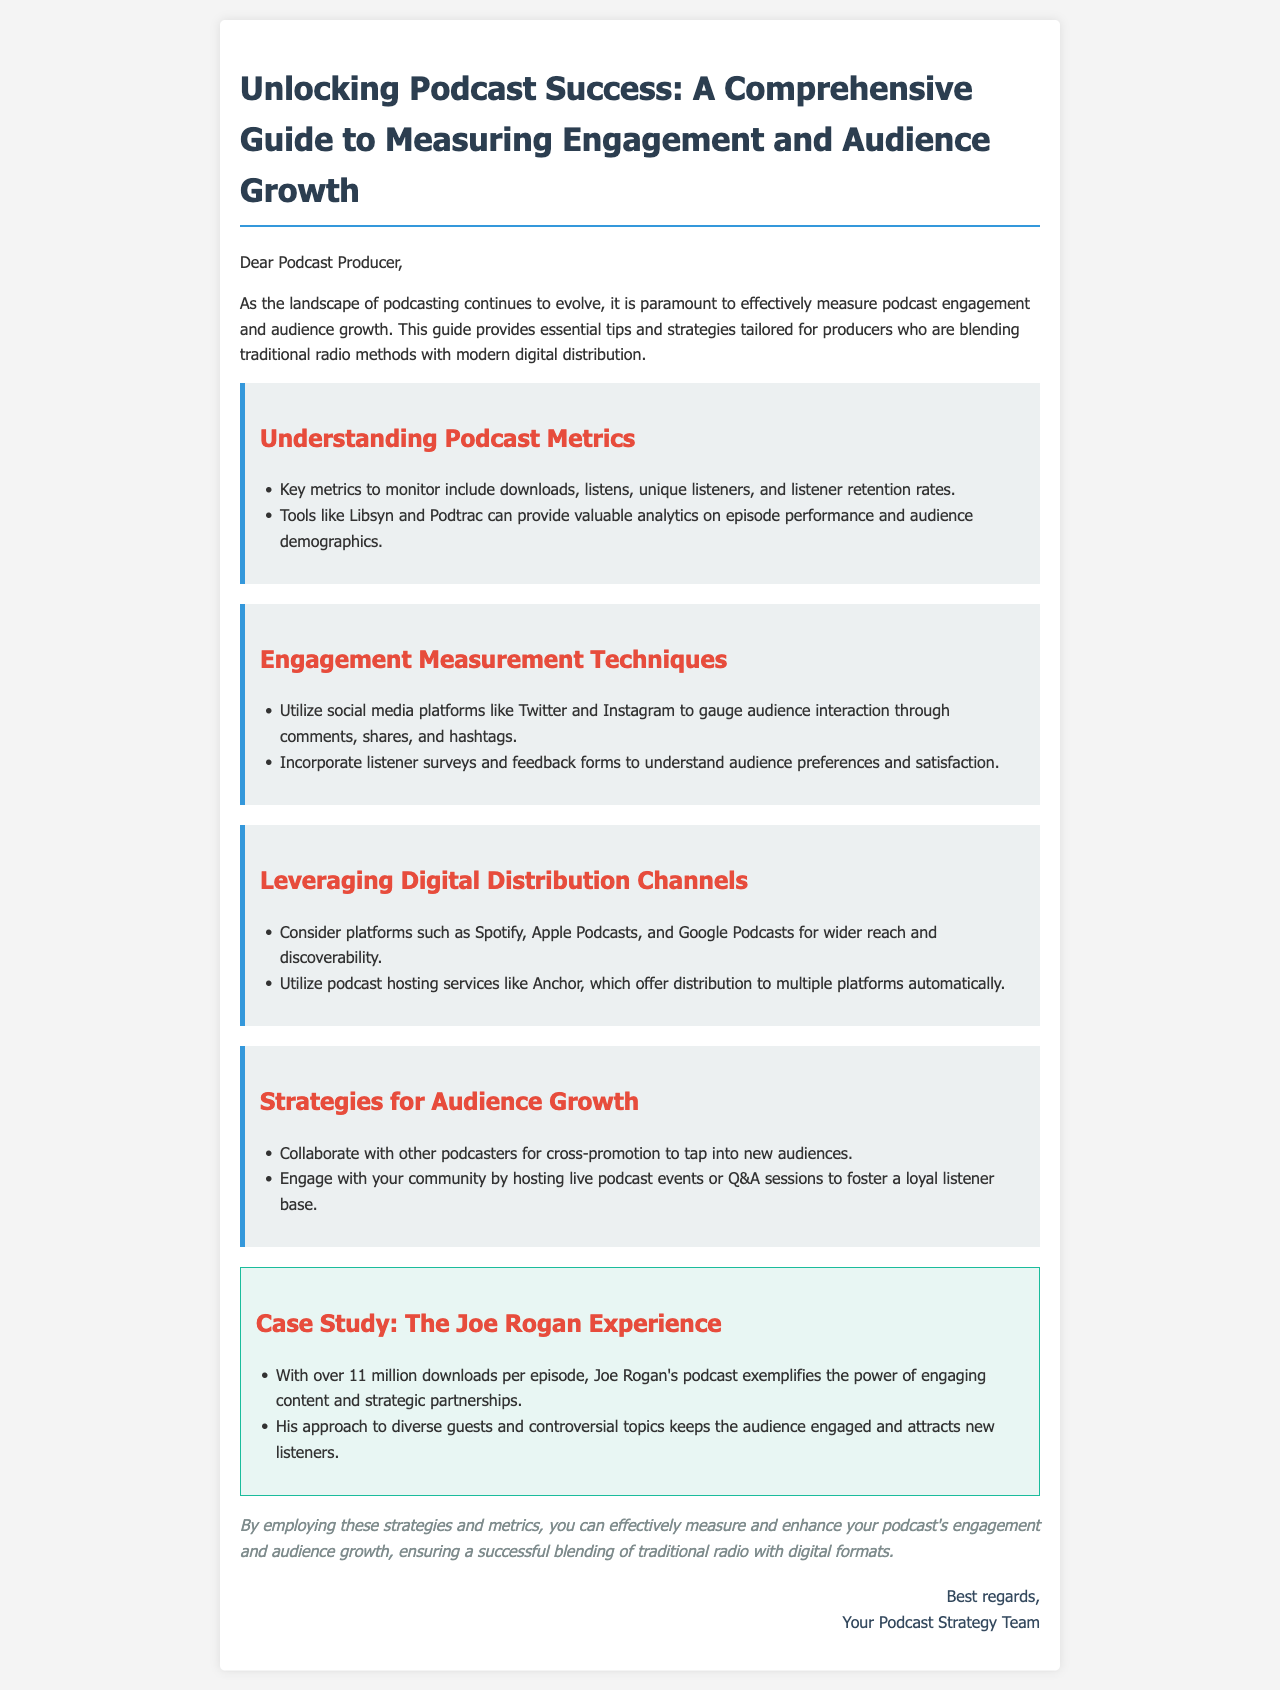what is the title of the guide? The title is clearly stated at the beginning of the document, which is about measuring engagement and audience growth in podcasts.
Answer: Unlocking Podcast Success: A Comprehensive Guide to Measuring Engagement and Audience Growth what is the first key metric to monitor? The document lists several key metrics, with the first mentioned being downloads.
Answer: downloads which tools are mentioned for analytics? The guide refers to specific tools for analyzing podcast performance.
Answer: Libsyn and Podtrac how many downloads per episode does The Joe Rogan Experience have? The case study provides a specific number regarding Joe Rogan's podcast.
Answer: over 11 million what platform is suggested for wider reach? The guide suggests a specific type of platform to enhance visibility.
Answer: Spotify what is a recommended engagement technique? The document provides a list of techniques, with one being particularly highlighted.
Answer: listener surveys what is one strategy for audience growth? The guide offers various strategies, and one is mentioned for collaboration.
Answer: cross-promotion what is suggested to utilize for automatic distribution? The document points out a specific hosting service that automates distribution.
Answer: Anchor 